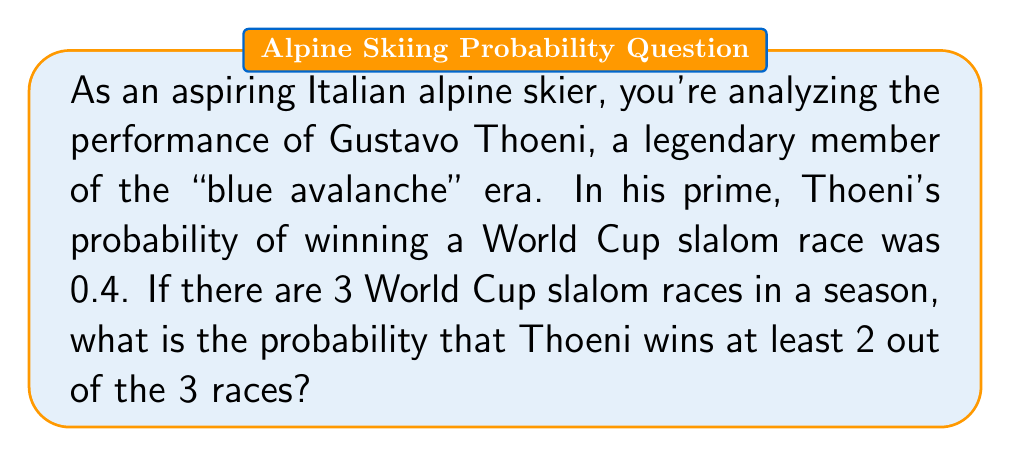Provide a solution to this math problem. To solve this problem, we'll use the binomial probability distribution. Let's break it down step-by-step:

1) We need to find P(X ≥ 2), where X is the number of races won.

2) This is equal to P(X = 2) + P(X = 3), as winning at least 2 races means winning either 2 or 3 races.

3) The probability of success (winning a race) is p = 0.4, and the probability of failure (not winning) is q = 1 - p = 0.6.

4) We'll use the binomial probability formula:

   $$P(X = k) = \binom{n}{k} p^k q^{n-k}$$

   where n is the number of trials (3 in this case) and k is the number of successes.

5) For X = 2:
   $$P(X = 2) = \binom{3}{2} (0.4)^2 (0.6)^1 = 3 \cdot 0.16 \cdot 0.6 = 0.288$$

6) For X = 3:
   $$P(X = 3) = \binom{3}{3} (0.4)^3 (0.6)^0 = 1 \cdot 0.064 \cdot 1 = 0.064$$

7) Therefore, P(X ≥ 2) = P(X = 2) + P(X = 3) = 0.288 + 0.064 = 0.352
Answer: The probability that Gustavo Thoeni wins at least 2 out of 3 World Cup slalom races in a season is 0.352 or 35.2%. 